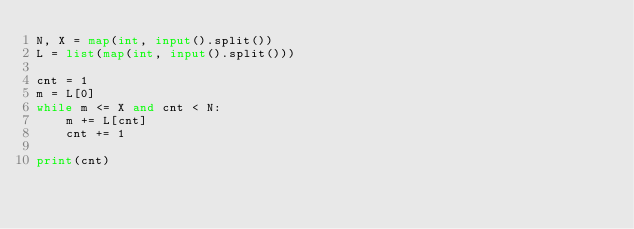<code> <loc_0><loc_0><loc_500><loc_500><_Python_>N, X = map(int, input().split())
L = list(map(int, input().split()))
 
cnt = 1
m = L[0]
while m <= X and cnt < N:
    m += L[cnt]
    cnt += 1

print(cnt)</code> 